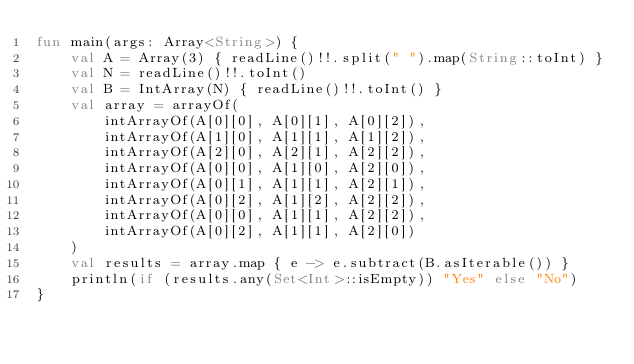Convert code to text. <code><loc_0><loc_0><loc_500><loc_500><_Kotlin_>fun main(args: Array<String>) {
    val A = Array(3) { readLine()!!.split(" ").map(String::toInt) }
    val N = readLine()!!.toInt()
    val B = IntArray(N) { readLine()!!.toInt() }
    val array = arrayOf(
        intArrayOf(A[0][0], A[0][1], A[0][2]),
        intArrayOf(A[1][0], A[1][1], A[1][2]),
        intArrayOf(A[2][0], A[2][1], A[2][2]),
        intArrayOf(A[0][0], A[1][0], A[2][0]),
        intArrayOf(A[0][1], A[1][1], A[2][1]),
        intArrayOf(A[0][2], A[1][2], A[2][2]),
        intArrayOf(A[0][0], A[1][1], A[2][2]),
        intArrayOf(A[0][2], A[1][1], A[2][0])
    )
    val results = array.map { e -> e.subtract(B.asIterable()) }
    println(if (results.any(Set<Int>::isEmpty)) "Yes" else "No")
}</code> 